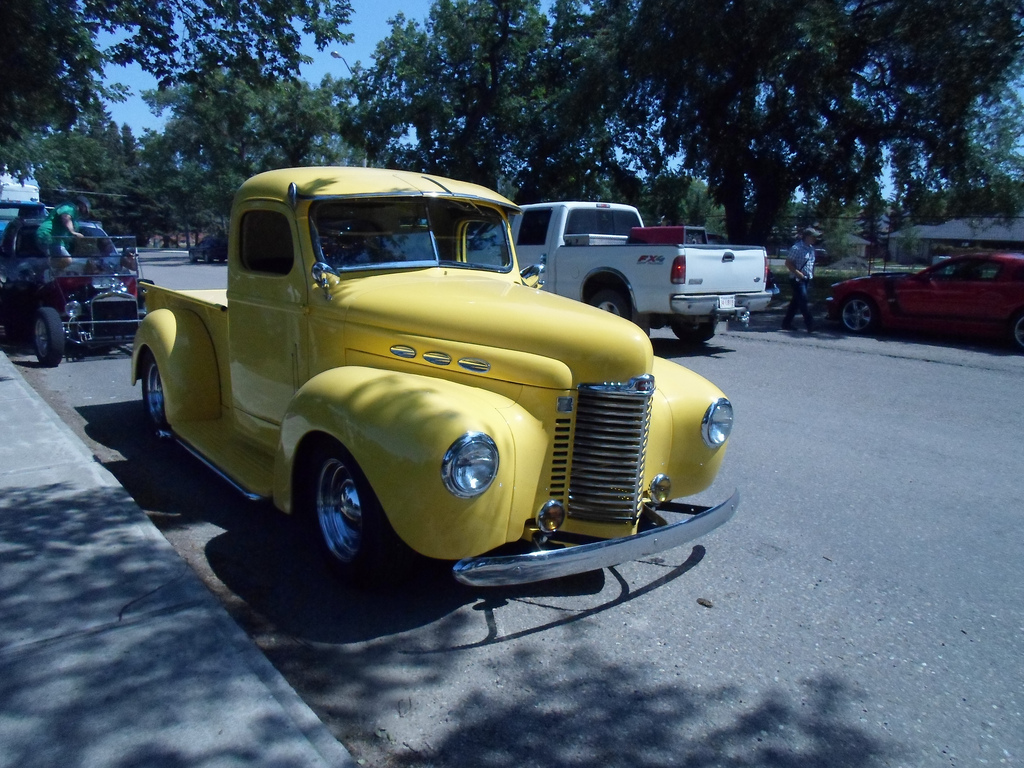Describe the style and era of the cars shown in this image. The cars displayed are primarily vintage models from the mid-20th century, characterized by their rounded body shapes and bright, eye-catching colors. This includes the prominent yellow truck and a classic red car, typical of the 1940s to 1960s era. 